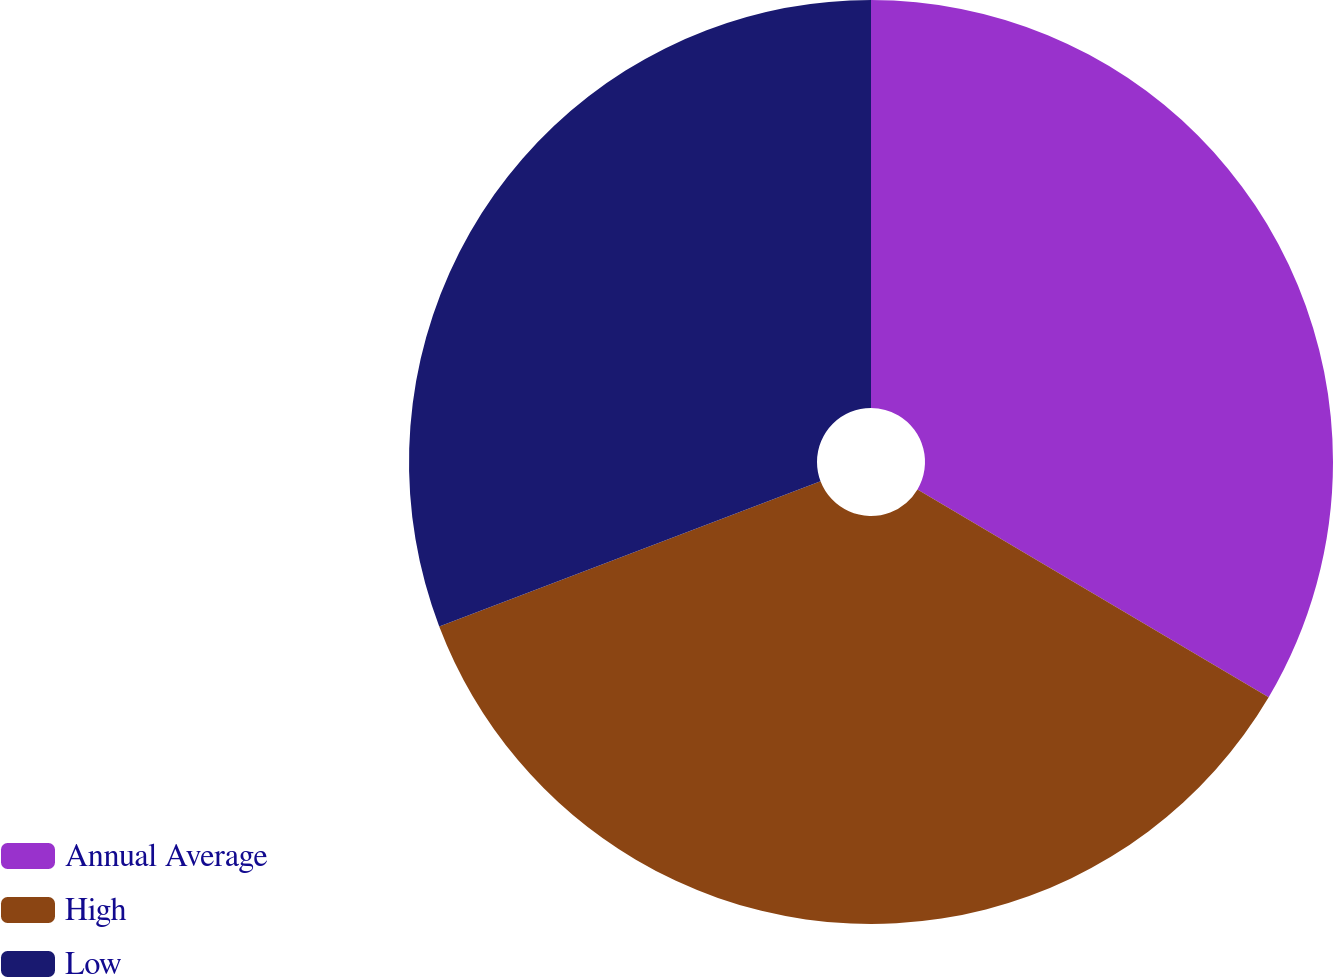Convert chart. <chart><loc_0><loc_0><loc_500><loc_500><pie_chart><fcel>Annual Average<fcel>High<fcel>Low<nl><fcel>33.5%<fcel>35.71%<fcel>30.79%<nl></chart> 